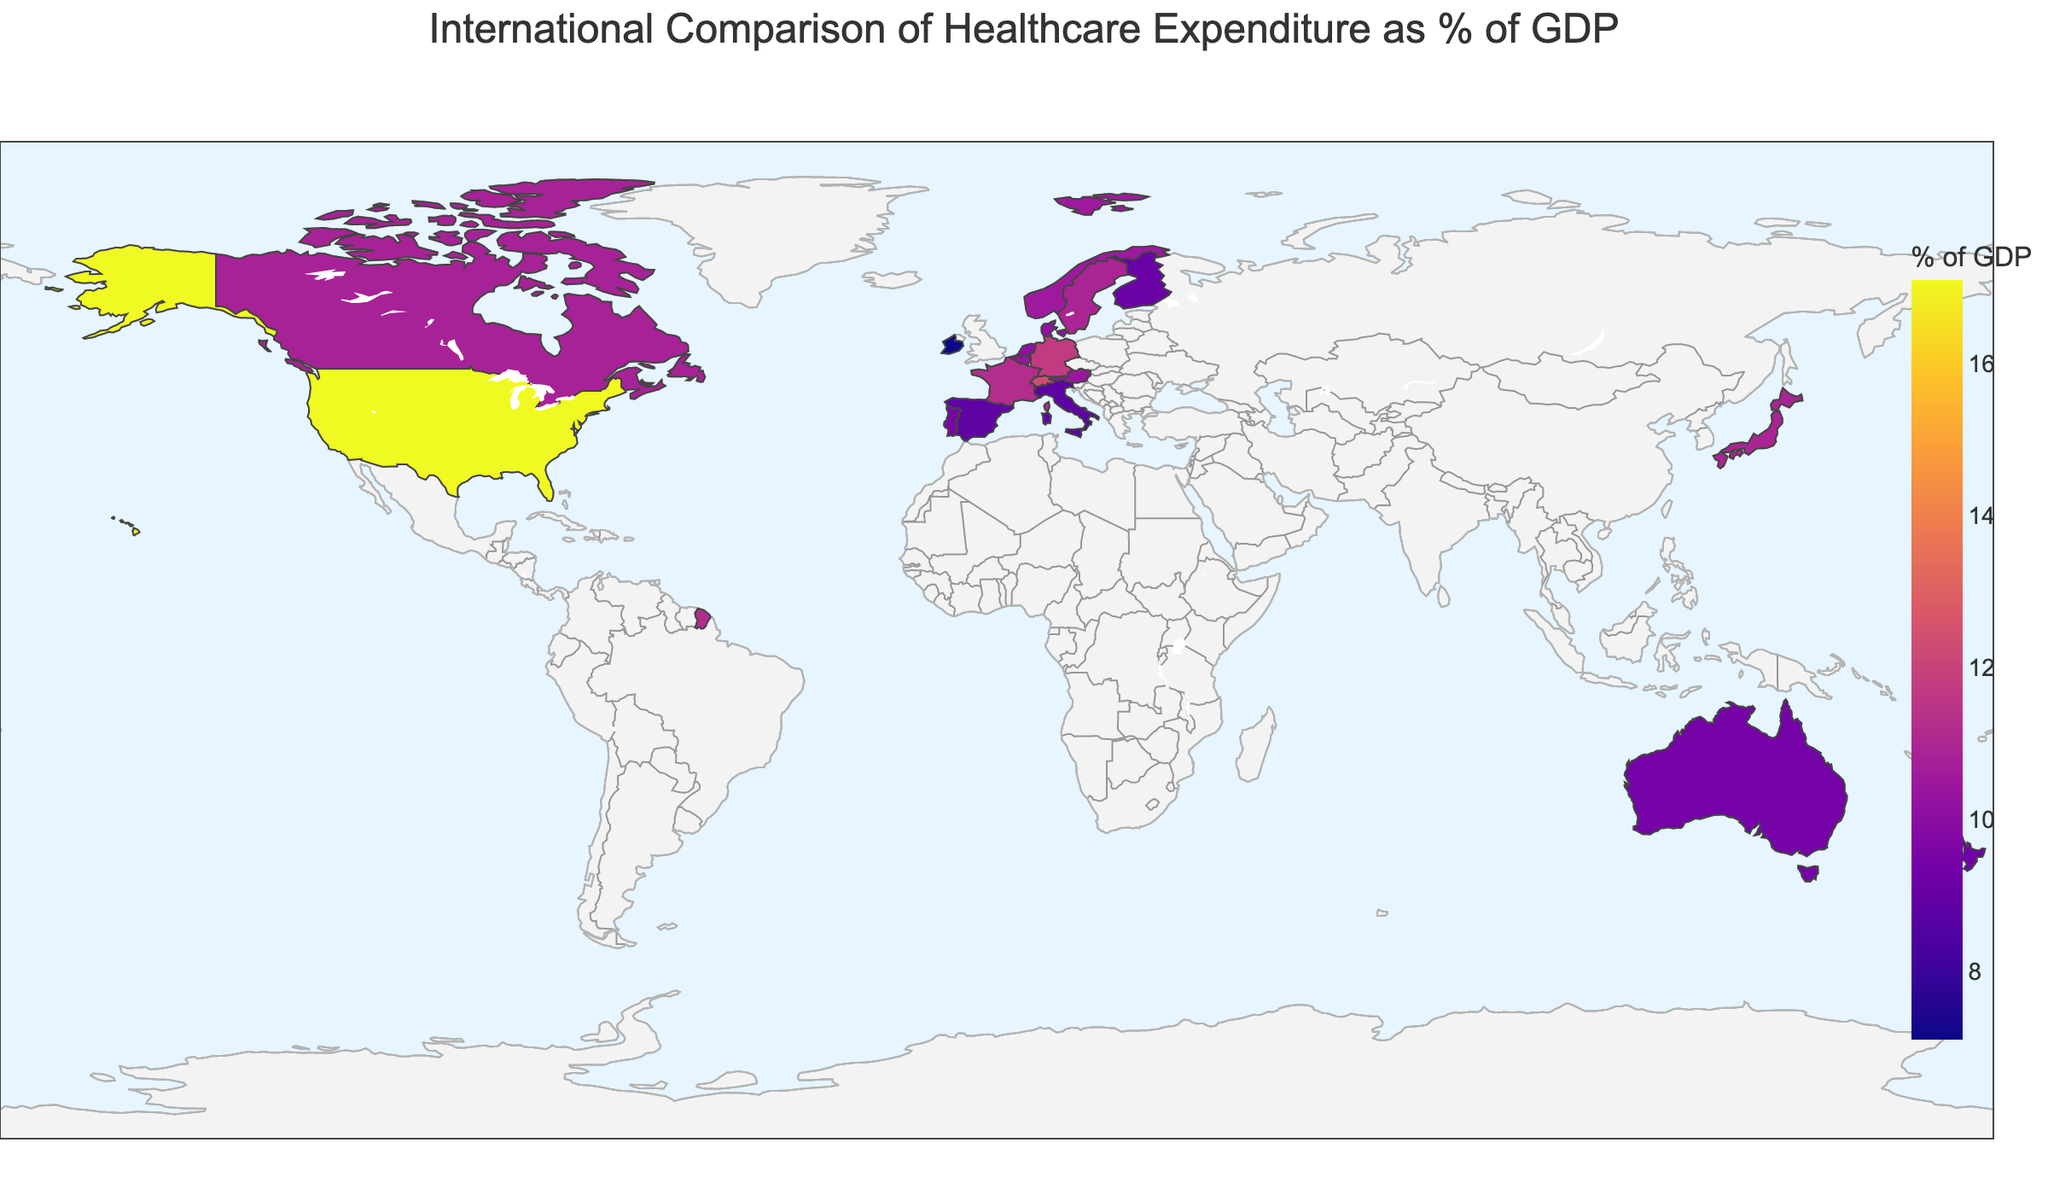Which country has the highest healthcare expenditure as a percentage of GDP? To find the country with the highest healthcare expenditure, look for the country with the most intense color (darkest according to the color scale) on the map. The label or tooltip might also show the exact values. The United States is the darkest.
Answer: United States Which country has the lowest healthcare expenditure as a percentage of GDP? Identify the country with the lightest color on the map. Hover or check for the lowest value displayed. Ireland is the lightest in color.
Answer: Ireland How does France's healthcare expenditure as a percentage of GDP compare to Germany's? Identify the locations and colors for France and Germany. Hover or check the values to compare the two. France has 11.2%, and Germany has 11.7%. Germany spends a higher percentage.
Answer: Germany spends more What's the combined healthcare expenditure percentage of GDP for Australia and New Zealand? Look for the values for Australia and New Zealand and add them. Australia: 9.4%, New Zealand: 9.3%. 9.4 + 9.3 = 18.7.
Answer: 18.7 Which countries have healthcare expenditures between 10% and 11% of GDP? Observe the map and hover/tooltips focusing on countries within this range. Netherlands (10.1), Sweden (10.9), Denmark (10.1), Belgium (10.3), Austria (10.4), and Norway (10.5) fall within this range.
Answer: Netherlands, Sweden, Denmark, Belgium, Austria, Norway What is the average healthcare expenditure as a percentage of GDP for countries shown on the map? Sum all the given percentages and divide by the number of countries. Calculation: (17.1 + 12.3 + 11.7 + 11.2 + 10.9 + 10.8 + 10.2 + 9.4 + 9.5 + 9.1 + 8.8 + 10.1 + 10.5 + 10.4 + 10.3 + 7.1) / 18 = approximately 10.59%.
Answer: 10.59 Which countries have higher healthcare expenditure than Canada? Identify Canada’s expenditure, then find countries with higher values. Canada has 10.8%. Higher: USA (17.1), Switzerland (12.3), Germany (11.7), France (11.2), Japan (10.9), Sweden (10.9).
Answer: USA, Switzerland, Germany, France, Japan, Sweden What region (continent) shows the most variation in healthcare expenditure as a percentage of GDP? Group countries by continent and analyze the range of expenditures in each. Europe shows the most variation with countries like Germany (11.7%), France (11.2%), Ireland (7.1%), Portugal (9.5%), etc.
Answer: Europe Which three countries have healthcare expenditures closest to the global average calculated earlier (10.59%)? Compare each country's healthcare expenditure to the calculated global average and find the three closest values. France (11.2), Japan (10.9), Canada (10.8). These are closest to 10.59%.
Answer: France, Japan, Canada 